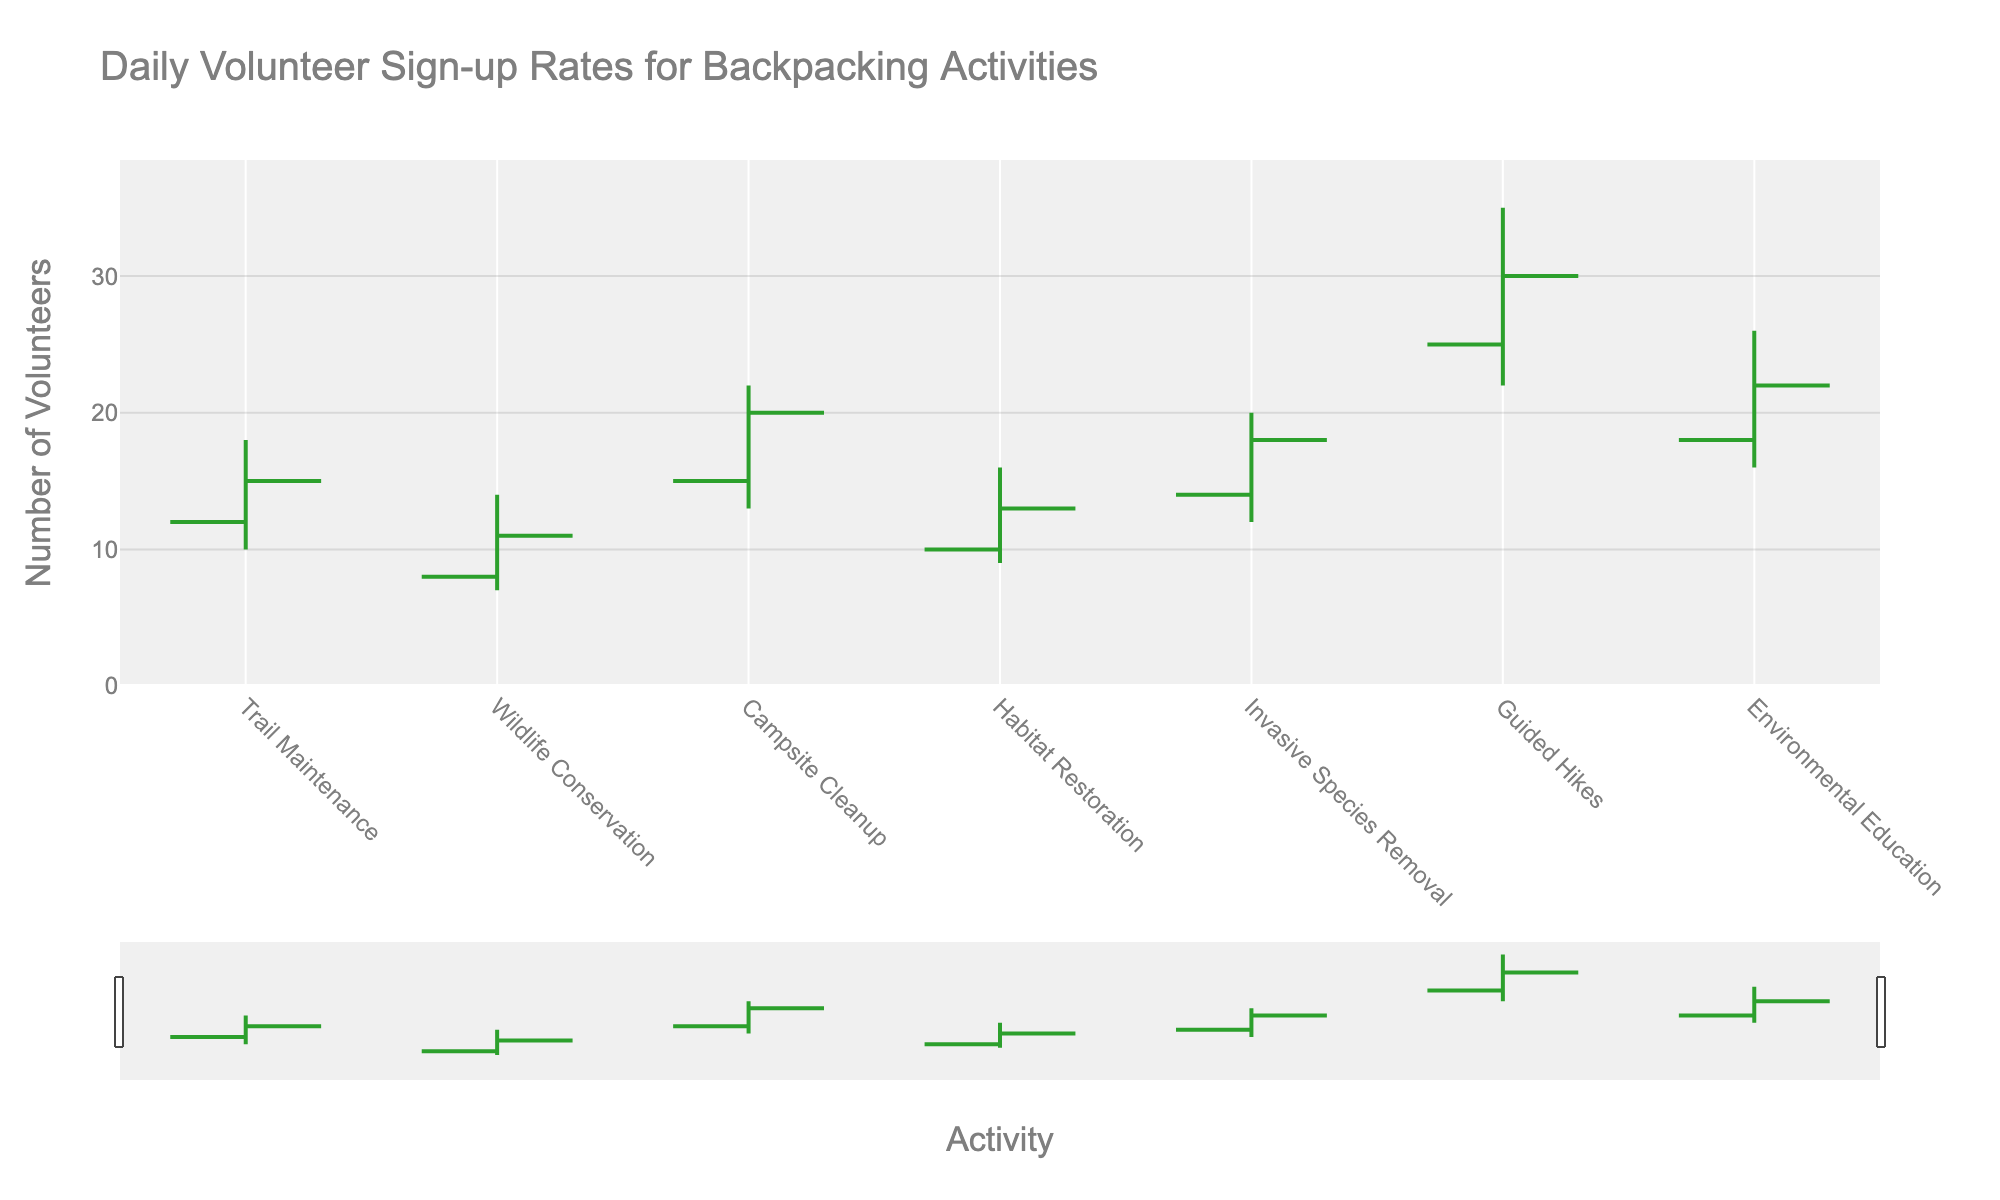What is the highest number of volunteer sign-ups recorded for "Guided Hikes"? The highest number is indicated by the 'High' value for "Guided Hikes". In this case, it's 35.
Answer: 35 What is the lowest number of volunteer sign-ups recorded on Tuesday? The lowest number is indicated by the 'Low' value for Tuesday's activity, "Wildlife Conservation", which is 7.
Answer: 7 Which activity had the highest closing number of volunteer sign-ups? The closing number of volunteer sign-ups is listed under the 'Close' column. "Guided Hikes" had the highest closing number, which is 30.
Answer: Guided Hikes How many activities had a closing value of more than 15 volunteers? Looking at the 'Close' values, we count the activities with closing values greater than 15: "Trail Maintenance" with 15 doesn't qualify, "Campsite Cleanup" (20), "Invasive Species Removal" (18), "Guided Hikes" (30), and "Environmental Education" (22). So, there are 4 such activities.
Answer: 4 Which activity had the smallest difference between its 'High' and 'Low' values? Calculate the difference between 'High' and 'Low' for each activity and identify the smallest value. "Wildlife Conservation" has the smallest difference of 14 - 7 = 7.
Answer: Wildlife Conservation On which day was there the largest fluctuation in volunteer sign-up rates? The largest fluctuation would be the highest difference between 'High' and 'Low' values. "Guided Hikes" has the greatest fluctuation of 35 - 22 = 13.
Answer: Guided Hikes (Saturday) What is the average opening value for all activities combined? Sum all 'Open' values and divide by the number of activities. The sum is 12 + 8 + 15 + 10 + 14 + 25 + 18 = 102. The average is 102 / 7 ≈ 14.57
Answer: 14.57 Compare the opening value of "Invasive Species Removal" to the closing value of "Trail Maintenance". Which is higher? Opening value of "Invasive Species Removal" is 14, and closing value of "Trail Maintenance" is 15. 15 is higher than 14.
Answer: Trail Maintenance Did any activity’s closing value equal its opening value? Compare the opening and closing values. None of the activities have the same opening and closing values.
Answer: No Which activity saw the greatest increase in volunteer sign-ups from open to close? Calculate the difference between the 'Close' and 'Open' values for each activity. "Campsite Cleanup" saw the largest increase of 20 - 15 = 5.
Answer: Campsite Cleanup 